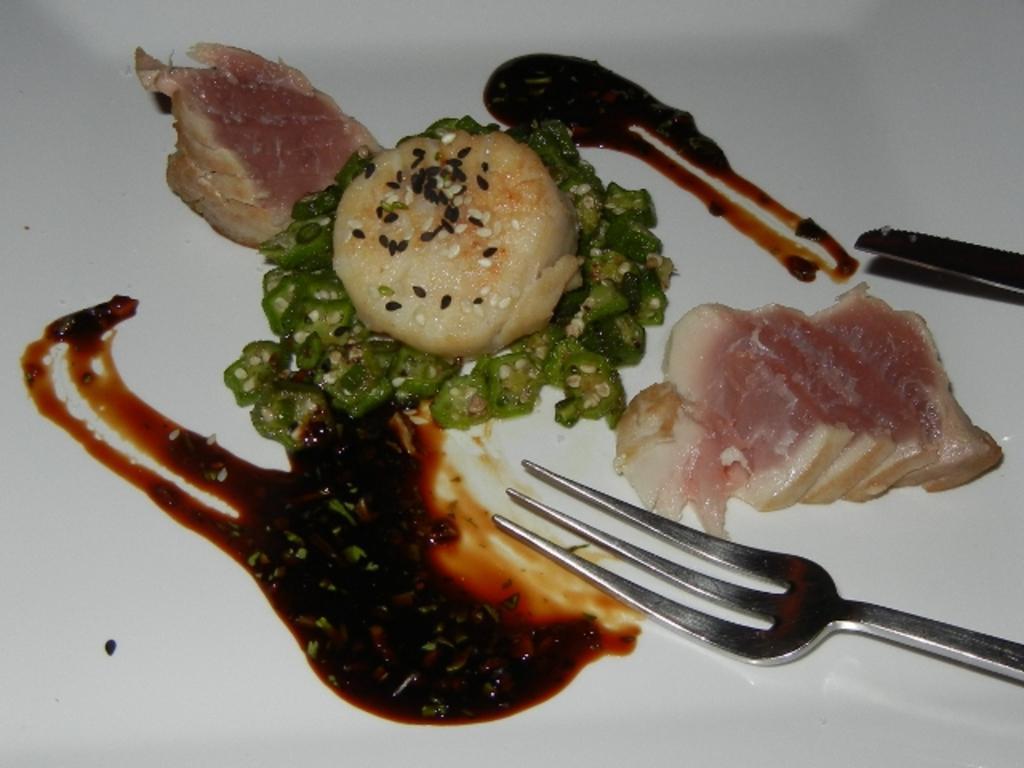Describe this image in one or two sentences. In this image we can see some food on the white surface and we can also see a fork. 